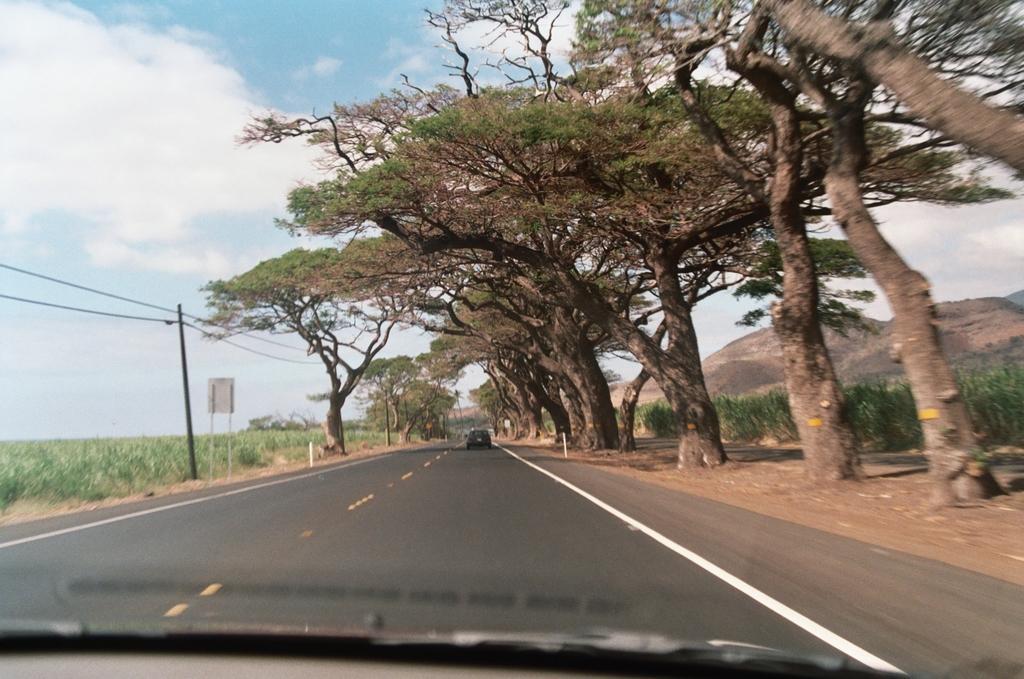Describe this image in one or two sentences. In this image we can see some vehicles on the road. We can also see a group of trees, plants, a board, an utility pole with wires, the hills and the sky which looks cloudy. 